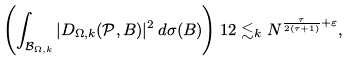Convert formula to latex. <formula><loc_0><loc_0><loc_500><loc_500>\left ( \int _ { { \mathcal { B } } _ { \Omega , k } } | D _ { \Omega , k } ( { \mathcal { P } } , B ) | ^ { 2 } \, d \sigma ( B ) \right ) ^ { } { 1 } 2 \lesssim _ { k } N ^ { \frac { \tau } { 2 ( \tau + 1 ) } + \varepsilon } ,</formula> 